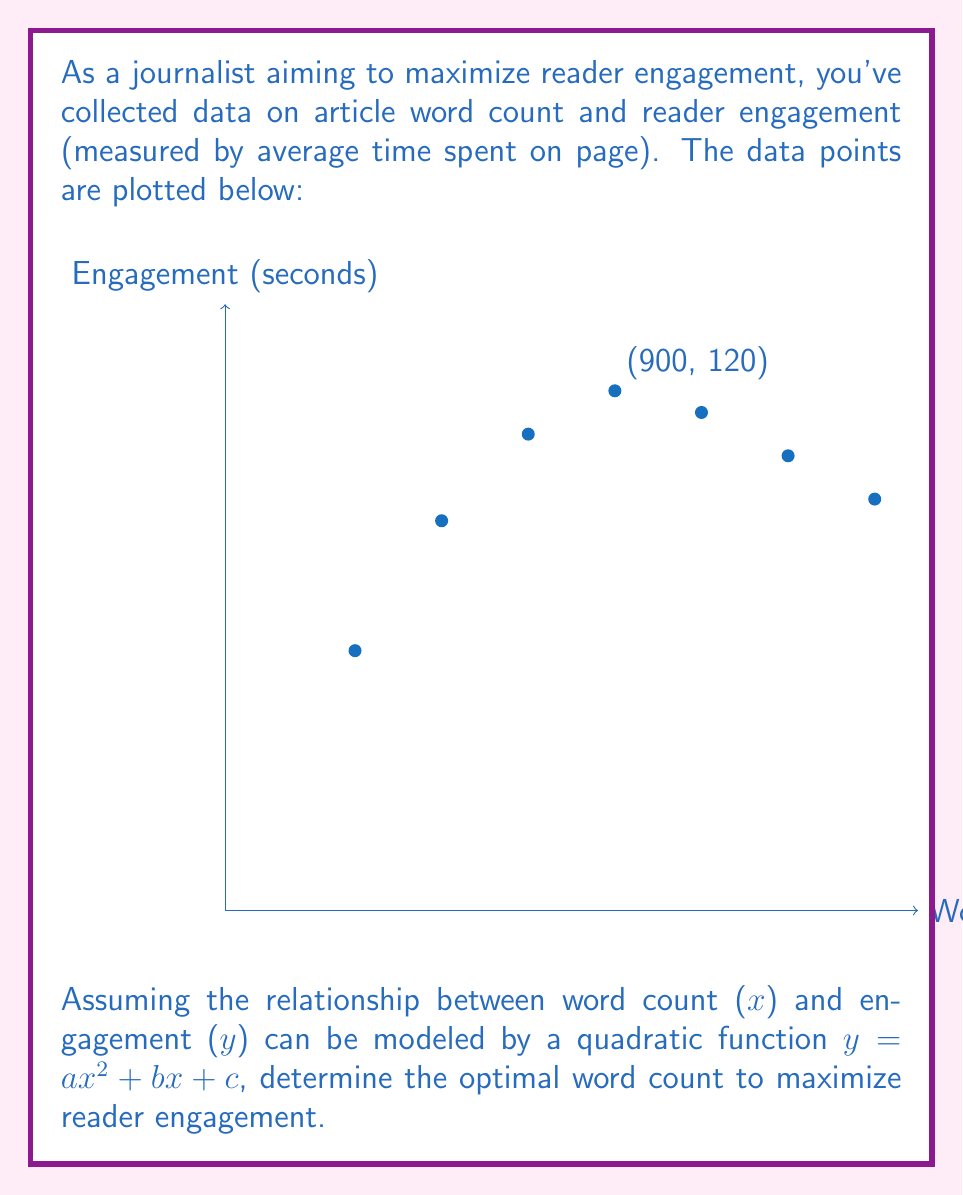Give your solution to this math problem. To solve this optimization problem, we'll follow these steps:

1) First, we need to find the quadratic function that best fits the data. We can use the vertex form of a quadratic function: $y = a(x-h)^2 + k$, where $(h,k)$ is the vertex.

2) From the graph, we can estimate that the vertex is around (900, 120). So, $h = 900$ and $k = 120$.

3) We can use one other point to find $a$. Let's use (300, 60):

   $60 = a(300-900)^2 + 120$
   $60 = a(-600)^2 + 120$
   $60 = 360000a + 120$
   $-60 = 360000a$
   $a = -\frac{1}{6000}$

4) Therefore, our quadratic function is:

   $y = -\frac{1}{6000}(x-900)^2 + 120$

5) To find the maximum engagement, we need to find the vertex of this parabola. The x-coordinate of the vertex is the optimal word count, which we've already identified as 900.

6) To verify, we can take the derivative of the function and set it to zero:

   $\frac{dy}{dx} = -\frac{1}{3000}(x-900)$

   Set this equal to zero:
   $-\frac{1}{3000}(x-900) = 0$
   $x-900 = 0$
   $x = 900$

This confirms that the optimal word count is 900 words.
Answer: 900 words 